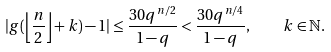Convert formula to latex. <formula><loc_0><loc_0><loc_500><loc_500>| g ( \left \lfloor \frac { n } { 2 } \right \rfloor + k ) - 1 | \leq \frac { 3 0 q ^ { n / 2 } } { 1 - q } < \frac { 3 0 q ^ { n / 4 } } { 1 - q } , \quad k \in \mathbb { N } .</formula> 